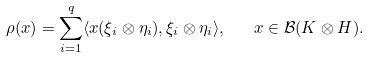Convert formula to latex. <formula><loc_0><loc_0><loc_500><loc_500>\rho ( x ) = \sum _ { i = 1 } ^ { q } \langle x ( \xi _ { i } \otimes \eta _ { i } ) , \xi _ { i } \otimes \eta _ { i } \rangle , \quad x \in \mathcal { B } ( K \otimes H ) .</formula> 